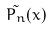Convert formula to latex. <formula><loc_0><loc_0><loc_500><loc_500>\tilde { P _ { n } } ( x )</formula> 